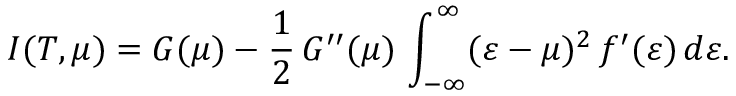Convert formula to latex. <formula><loc_0><loc_0><loc_500><loc_500>I ( T , \mu ) = G ( \mu ) - \frac { 1 } { 2 } \, G ^ { \prime \prime } ( \mu ) \, \int _ { - \infty } ^ { \infty } ( \varepsilon - \mu ) ^ { 2 } \, f ^ { \prime } ( \varepsilon ) \, d \varepsilon .</formula> 